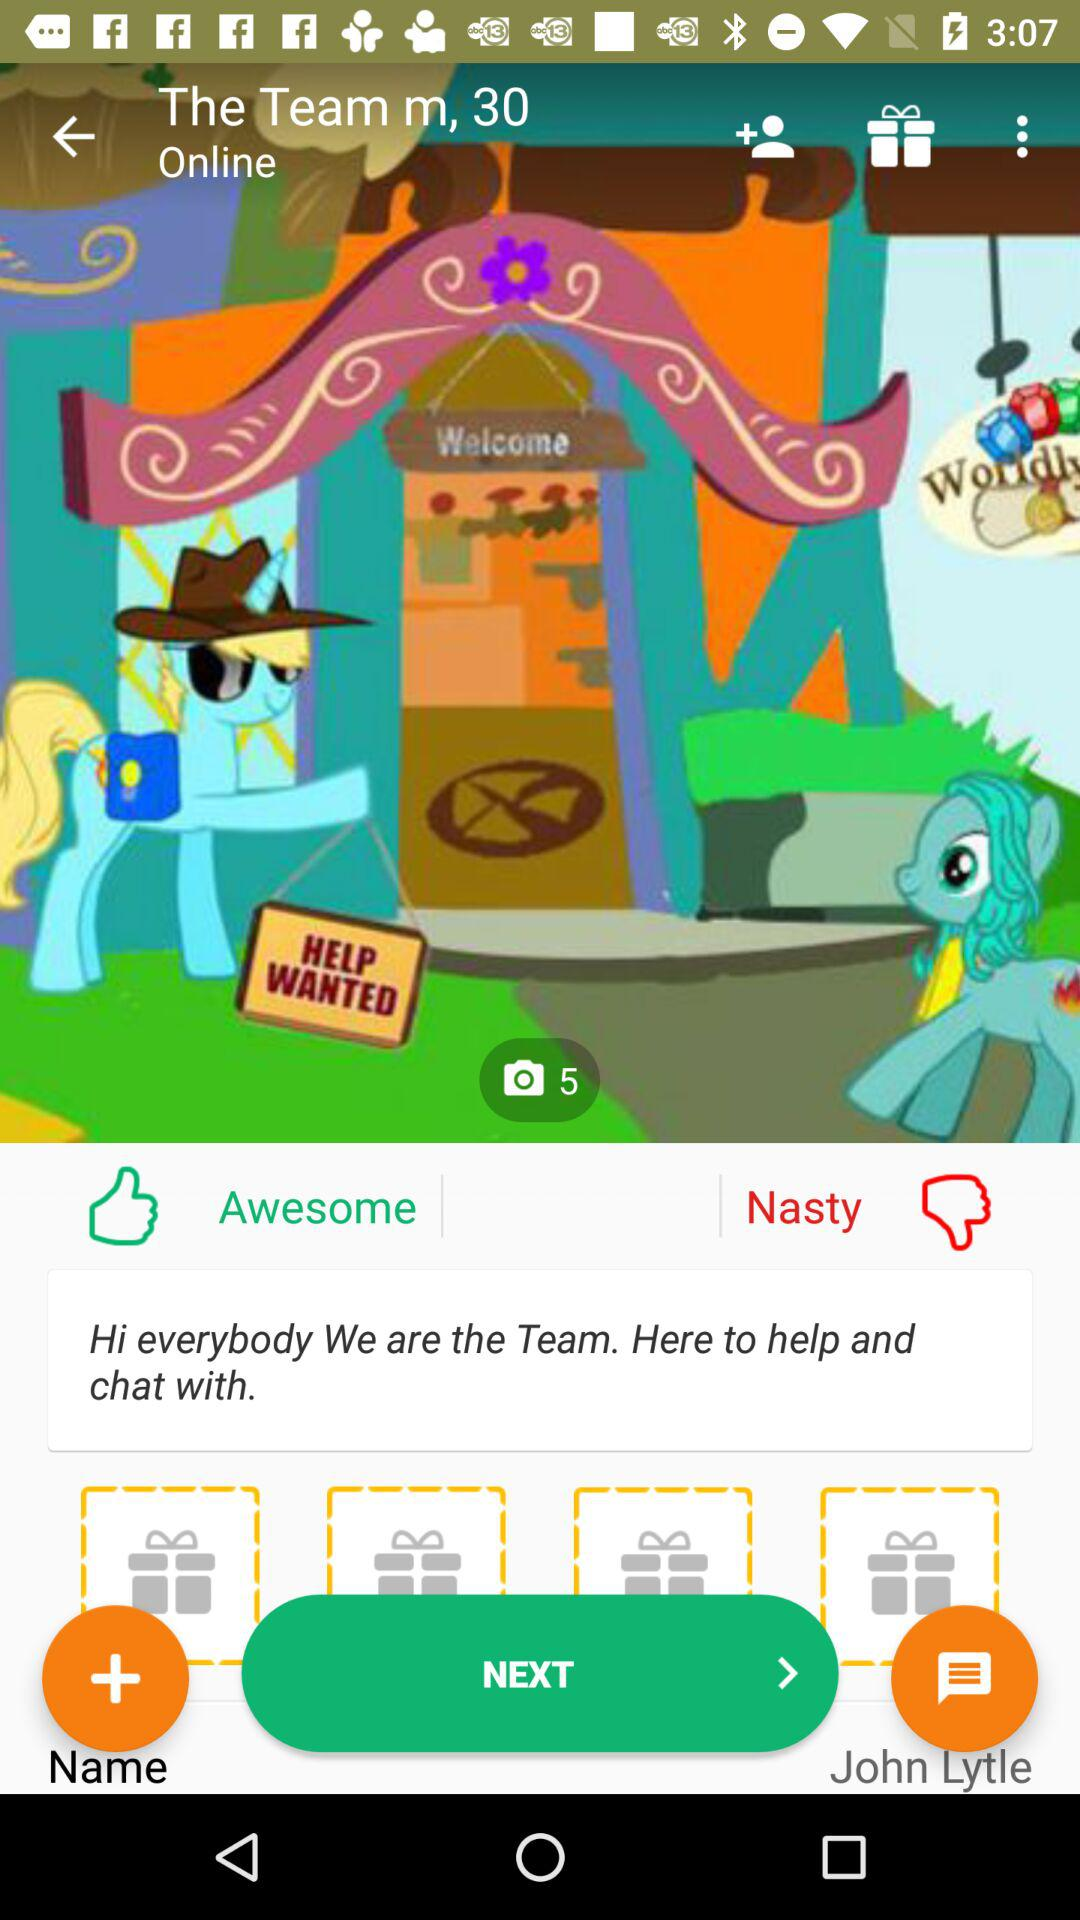How many images in total are there? The total number of images is 5. 